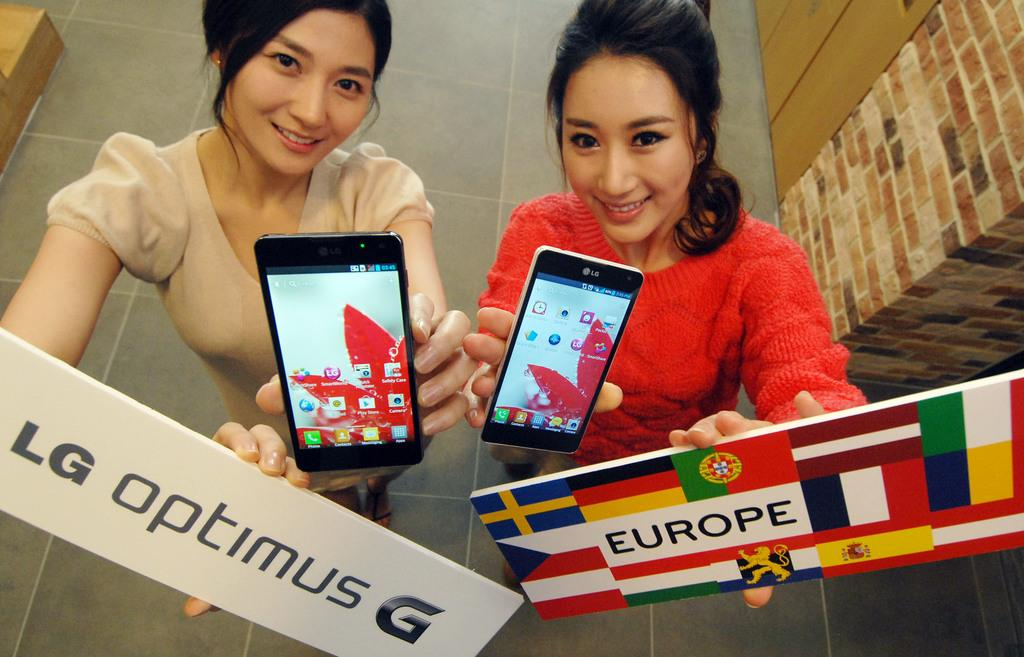<image>
Create a compact narrative representing the image presented. Two women hold cell phones in one hand and one holds a sign that says LG Optimus while the other holds a sign that says Europe. 